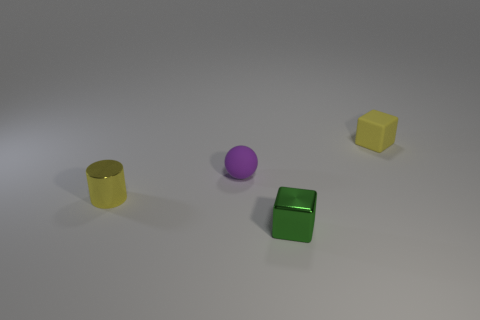Subtract all yellow cubes. How many cubes are left? 1 Add 4 gray blocks. How many objects exist? 8 Subtract all cylinders. How many objects are left? 3 Subtract all purple cylinders. How many yellow cubes are left? 1 Subtract all green metal cubes. Subtract all small yellow rubber blocks. How many objects are left? 2 Add 2 small metal cylinders. How many small metal cylinders are left? 3 Add 1 tiny shiny cubes. How many tiny shiny cubes exist? 2 Subtract 1 purple spheres. How many objects are left? 3 Subtract all purple blocks. Subtract all green spheres. How many blocks are left? 2 